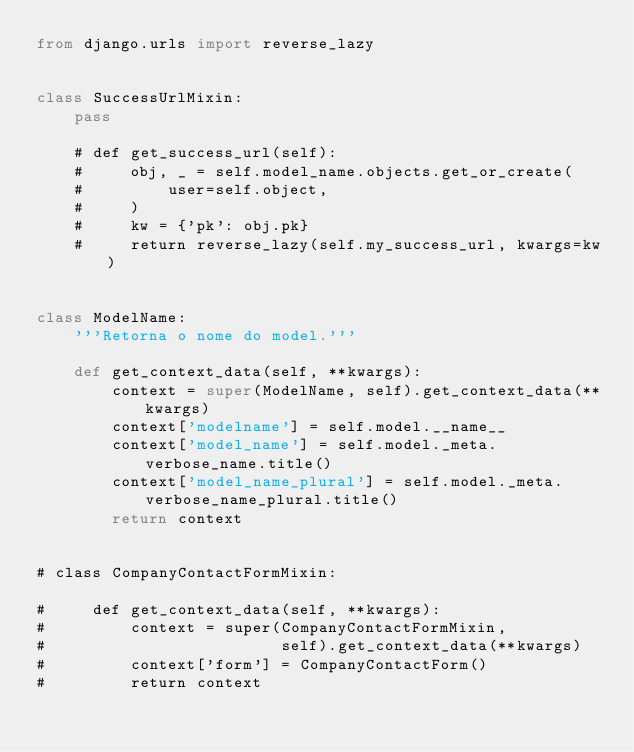<code> <loc_0><loc_0><loc_500><loc_500><_Python_>from django.urls import reverse_lazy


class SuccessUrlMixin:
    pass

    # def get_success_url(self):
    #     obj, _ = self.model_name.objects.get_or_create(
    #         user=self.object,
    #     )
    #     kw = {'pk': obj.pk}
    #     return reverse_lazy(self.my_success_url, kwargs=kw)


class ModelName:
    '''Retorna o nome do model.'''

    def get_context_data(self, **kwargs):
        context = super(ModelName, self).get_context_data(**kwargs)
        context['modelname'] = self.model.__name__
        context['model_name'] = self.model._meta.verbose_name.title()
        context['model_name_plural'] = self.model._meta.verbose_name_plural.title()
        return context


# class CompanyContactFormMixin:

#     def get_context_data(self, **kwargs):
#         context = super(CompanyContactFormMixin,
#                         self).get_context_data(**kwargs)
#         context['form'] = CompanyContactForm()
#         return context
</code> 